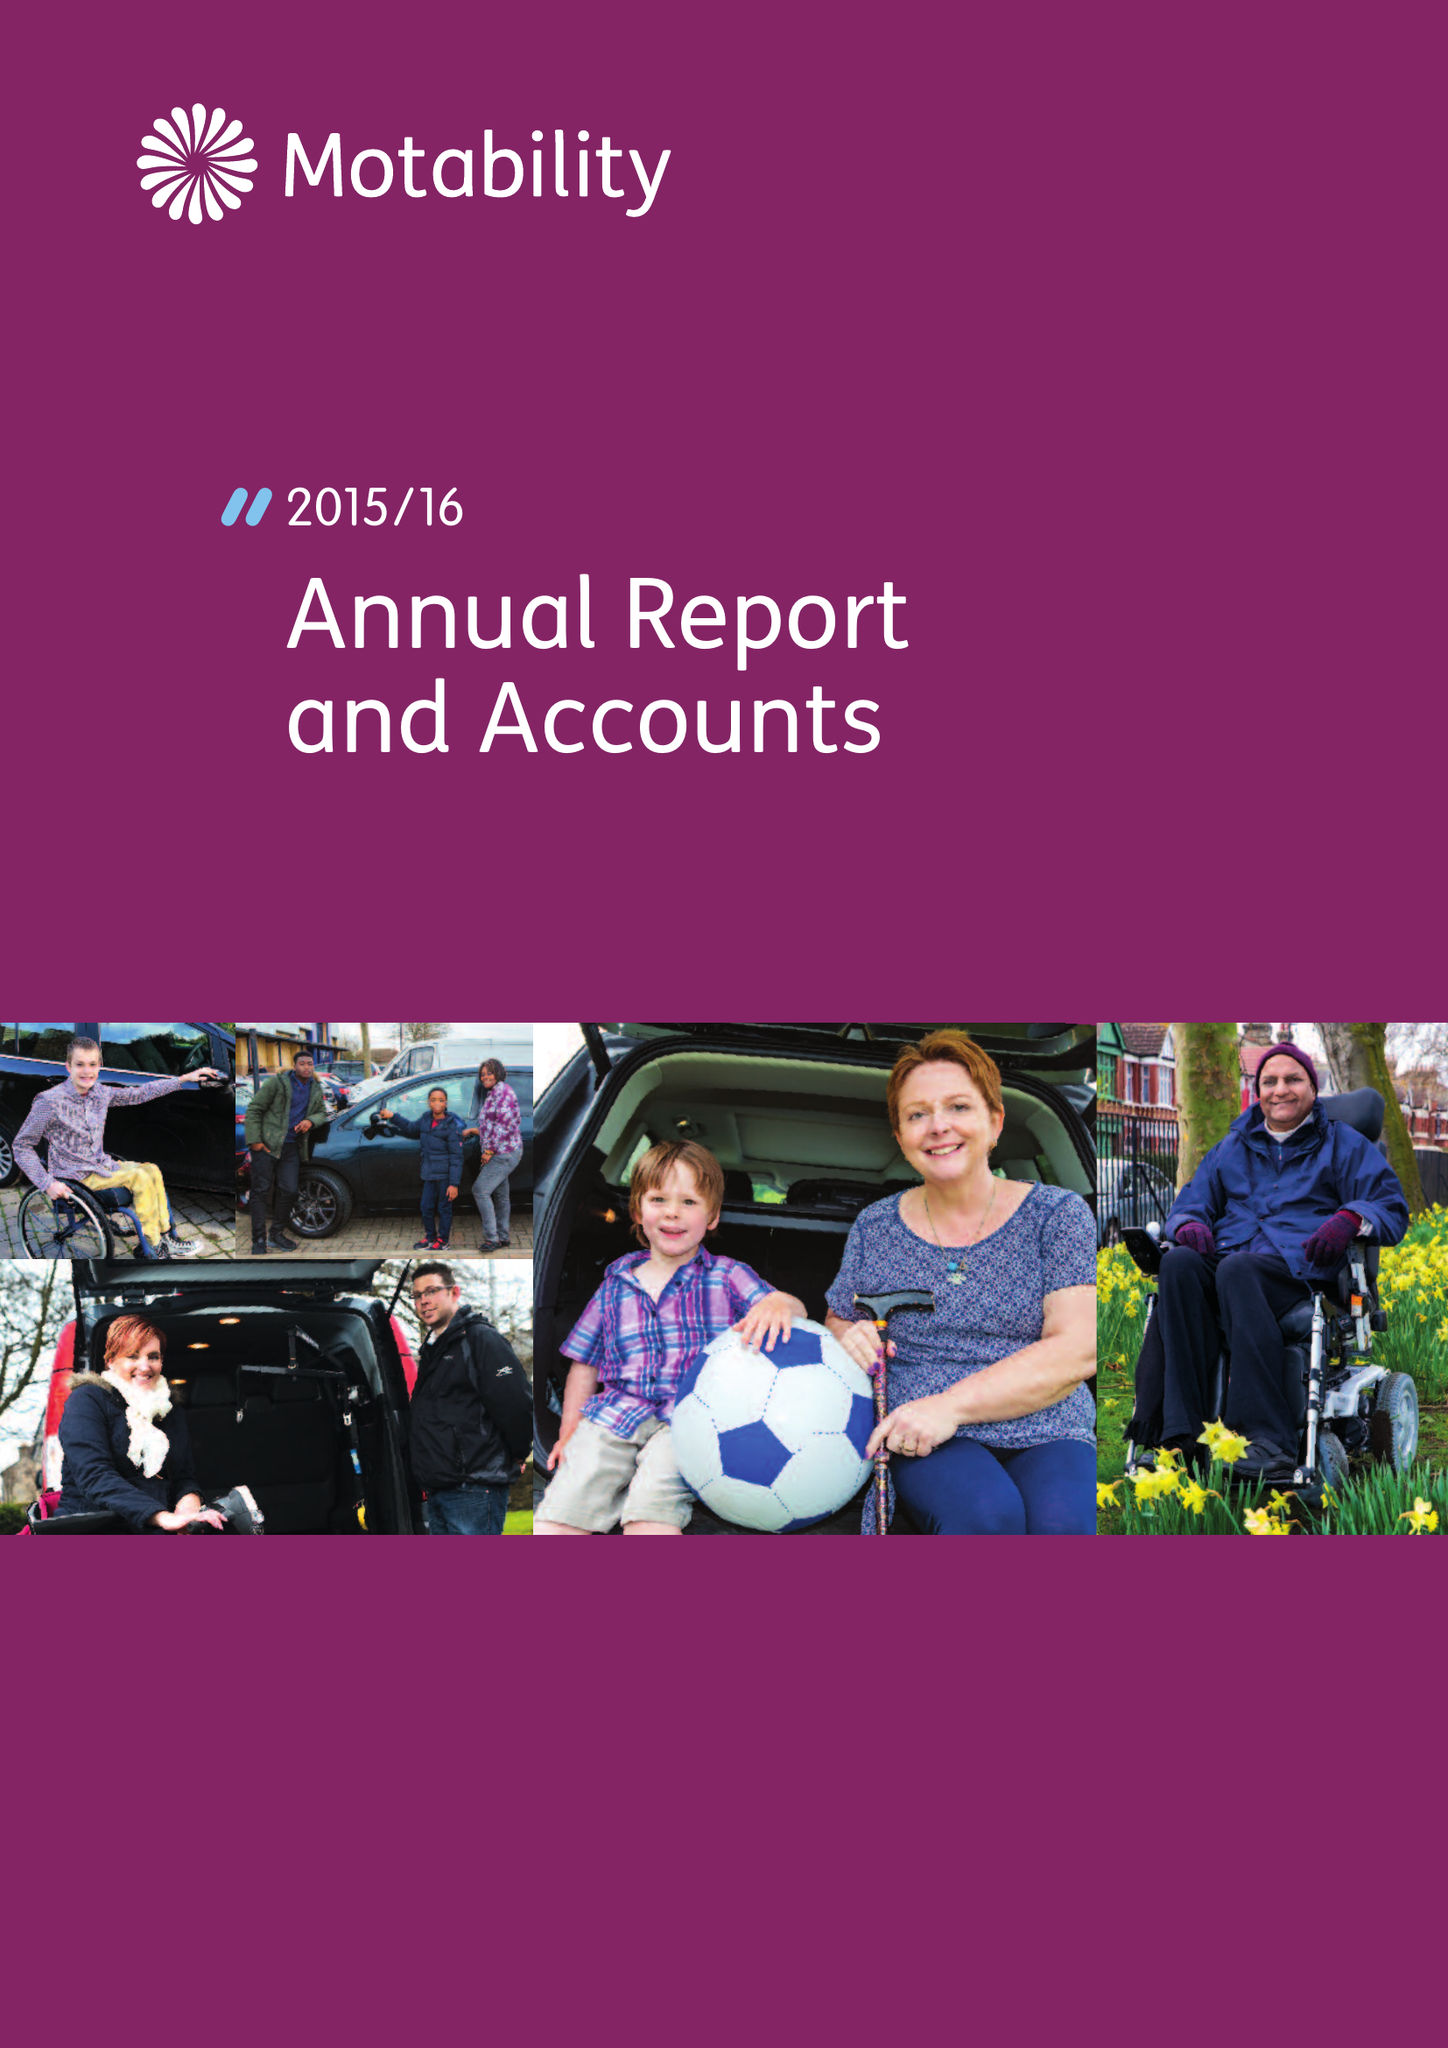What is the value for the spending_annually_in_british_pounds?
Answer the question using a single word or phrase. 66084000.00 